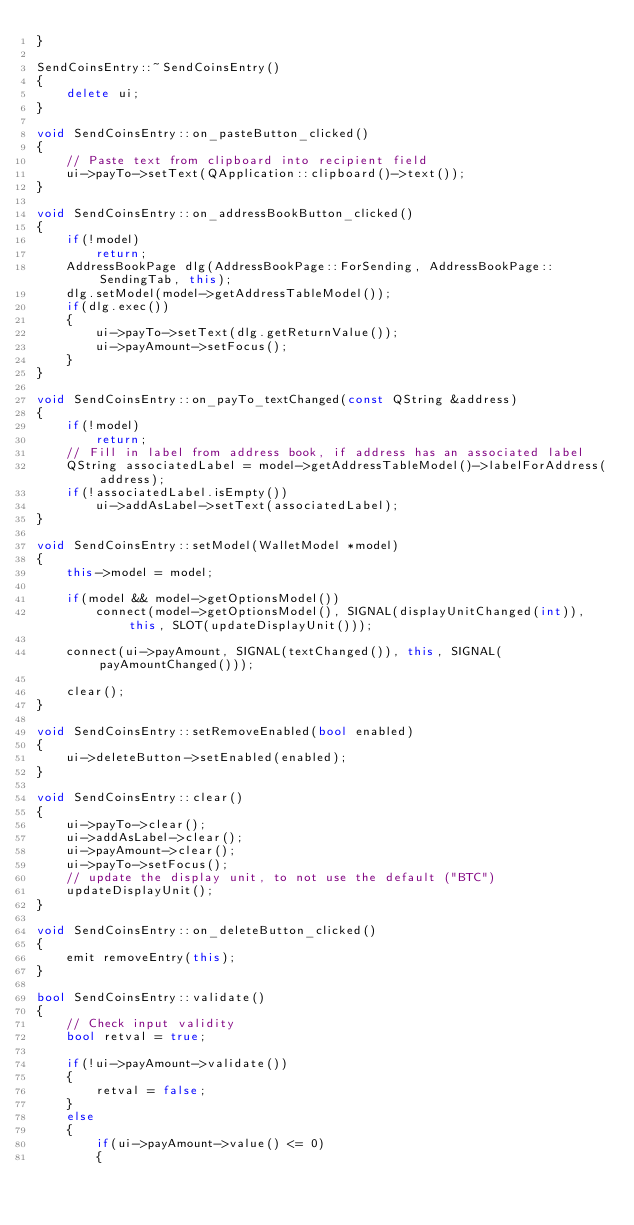<code> <loc_0><loc_0><loc_500><loc_500><_C++_>}

SendCoinsEntry::~SendCoinsEntry()
{
    delete ui;
}

void SendCoinsEntry::on_pasteButton_clicked()
{
    // Paste text from clipboard into recipient field
    ui->payTo->setText(QApplication::clipboard()->text());
}

void SendCoinsEntry::on_addressBookButton_clicked()
{
    if(!model)
        return;
    AddressBookPage dlg(AddressBookPage::ForSending, AddressBookPage::SendingTab, this);
    dlg.setModel(model->getAddressTableModel());
    if(dlg.exec())
    {
        ui->payTo->setText(dlg.getReturnValue());
        ui->payAmount->setFocus();
    }
}

void SendCoinsEntry::on_payTo_textChanged(const QString &address)
{
    if(!model)
        return;
    // Fill in label from address book, if address has an associated label
    QString associatedLabel = model->getAddressTableModel()->labelForAddress(address);
    if(!associatedLabel.isEmpty())
        ui->addAsLabel->setText(associatedLabel);
}

void SendCoinsEntry::setModel(WalletModel *model)
{
    this->model = model;

    if(model && model->getOptionsModel())
        connect(model->getOptionsModel(), SIGNAL(displayUnitChanged(int)), this, SLOT(updateDisplayUnit()));

    connect(ui->payAmount, SIGNAL(textChanged()), this, SIGNAL(payAmountChanged()));

    clear();
}

void SendCoinsEntry::setRemoveEnabled(bool enabled)
{
    ui->deleteButton->setEnabled(enabled);
}

void SendCoinsEntry::clear()
{
    ui->payTo->clear();
    ui->addAsLabel->clear();
    ui->payAmount->clear();
    ui->payTo->setFocus();
    // update the display unit, to not use the default ("BTC")
    updateDisplayUnit();
}

void SendCoinsEntry::on_deleteButton_clicked()
{
    emit removeEntry(this);
}

bool SendCoinsEntry::validate()
{
    // Check input validity
    bool retval = true;

    if(!ui->payAmount->validate())
    {
        retval = false;
    }
    else
    {
        if(ui->payAmount->value() <= 0)
        {</code> 